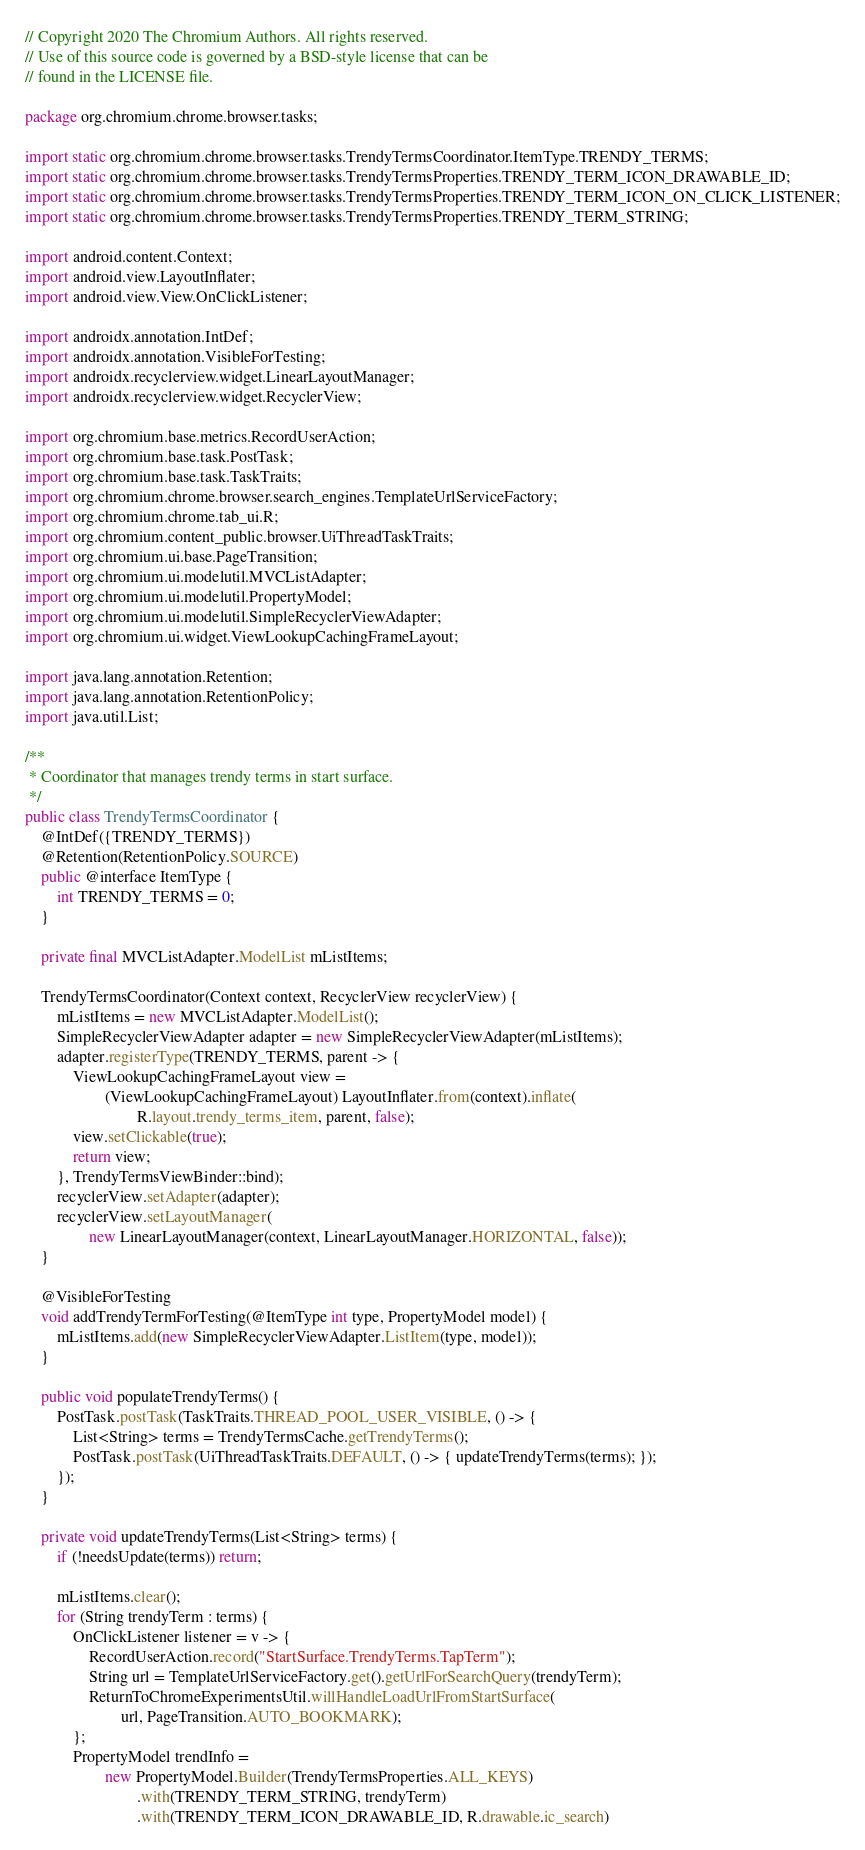<code> <loc_0><loc_0><loc_500><loc_500><_Java_>// Copyright 2020 The Chromium Authors. All rights reserved.
// Use of this source code is governed by a BSD-style license that can be
// found in the LICENSE file.

package org.chromium.chrome.browser.tasks;

import static org.chromium.chrome.browser.tasks.TrendyTermsCoordinator.ItemType.TRENDY_TERMS;
import static org.chromium.chrome.browser.tasks.TrendyTermsProperties.TRENDY_TERM_ICON_DRAWABLE_ID;
import static org.chromium.chrome.browser.tasks.TrendyTermsProperties.TRENDY_TERM_ICON_ON_CLICK_LISTENER;
import static org.chromium.chrome.browser.tasks.TrendyTermsProperties.TRENDY_TERM_STRING;

import android.content.Context;
import android.view.LayoutInflater;
import android.view.View.OnClickListener;

import androidx.annotation.IntDef;
import androidx.annotation.VisibleForTesting;
import androidx.recyclerview.widget.LinearLayoutManager;
import androidx.recyclerview.widget.RecyclerView;

import org.chromium.base.metrics.RecordUserAction;
import org.chromium.base.task.PostTask;
import org.chromium.base.task.TaskTraits;
import org.chromium.chrome.browser.search_engines.TemplateUrlServiceFactory;
import org.chromium.chrome.tab_ui.R;
import org.chromium.content_public.browser.UiThreadTaskTraits;
import org.chromium.ui.base.PageTransition;
import org.chromium.ui.modelutil.MVCListAdapter;
import org.chromium.ui.modelutil.PropertyModel;
import org.chromium.ui.modelutil.SimpleRecyclerViewAdapter;
import org.chromium.ui.widget.ViewLookupCachingFrameLayout;

import java.lang.annotation.Retention;
import java.lang.annotation.RetentionPolicy;
import java.util.List;

/**
 * Coordinator that manages trendy terms in start surface.
 */
public class TrendyTermsCoordinator {
    @IntDef({TRENDY_TERMS})
    @Retention(RetentionPolicy.SOURCE)
    public @interface ItemType {
        int TRENDY_TERMS = 0;
    }

    private final MVCListAdapter.ModelList mListItems;

    TrendyTermsCoordinator(Context context, RecyclerView recyclerView) {
        mListItems = new MVCListAdapter.ModelList();
        SimpleRecyclerViewAdapter adapter = new SimpleRecyclerViewAdapter(mListItems);
        adapter.registerType(TRENDY_TERMS, parent -> {
            ViewLookupCachingFrameLayout view =
                    (ViewLookupCachingFrameLayout) LayoutInflater.from(context).inflate(
                            R.layout.trendy_terms_item, parent, false);
            view.setClickable(true);
            return view;
        }, TrendyTermsViewBinder::bind);
        recyclerView.setAdapter(adapter);
        recyclerView.setLayoutManager(
                new LinearLayoutManager(context, LinearLayoutManager.HORIZONTAL, false));
    }

    @VisibleForTesting
    void addTrendyTermForTesting(@ItemType int type, PropertyModel model) {
        mListItems.add(new SimpleRecyclerViewAdapter.ListItem(type, model));
    }

    public void populateTrendyTerms() {
        PostTask.postTask(TaskTraits.THREAD_POOL_USER_VISIBLE, () -> {
            List<String> terms = TrendyTermsCache.getTrendyTerms();
            PostTask.postTask(UiThreadTaskTraits.DEFAULT, () -> { updateTrendyTerms(terms); });
        });
    }

    private void updateTrendyTerms(List<String> terms) {
        if (!needsUpdate(terms)) return;

        mListItems.clear();
        for (String trendyTerm : terms) {
            OnClickListener listener = v -> {
                RecordUserAction.record("StartSurface.TrendyTerms.TapTerm");
                String url = TemplateUrlServiceFactory.get().getUrlForSearchQuery(trendyTerm);
                ReturnToChromeExperimentsUtil.willHandleLoadUrlFromStartSurface(
                        url, PageTransition.AUTO_BOOKMARK);
            };
            PropertyModel trendInfo =
                    new PropertyModel.Builder(TrendyTermsProperties.ALL_KEYS)
                            .with(TRENDY_TERM_STRING, trendyTerm)
                            .with(TRENDY_TERM_ICON_DRAWABLE_ID, R.drawable.ic_search)</code> 